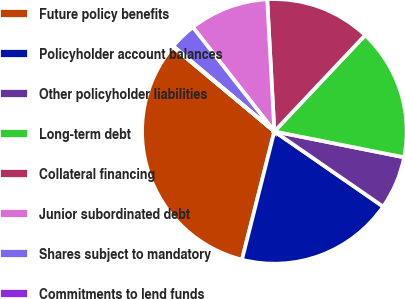Convert chart. <chart><loc_0><loc_0><loc_500><loc_500><pie_chart><fcel>Future policy benefits<fcel>Policyholder account balances<fcel>Other policyholder liabilities<fcel>Long-term debt<fcel>Collateral financing<fcel>Junior subordinated debt<fcel>Shares subject to mandatory<fcel>Commitments to lend funds<nl><fcel>32.12%<fcel>19.31%<fcel>6.49%<fcel>16.1%<fcel>12.9%<fcel>9.7%<fcel>3.29%<fcel>0.09%<nl></chart> 